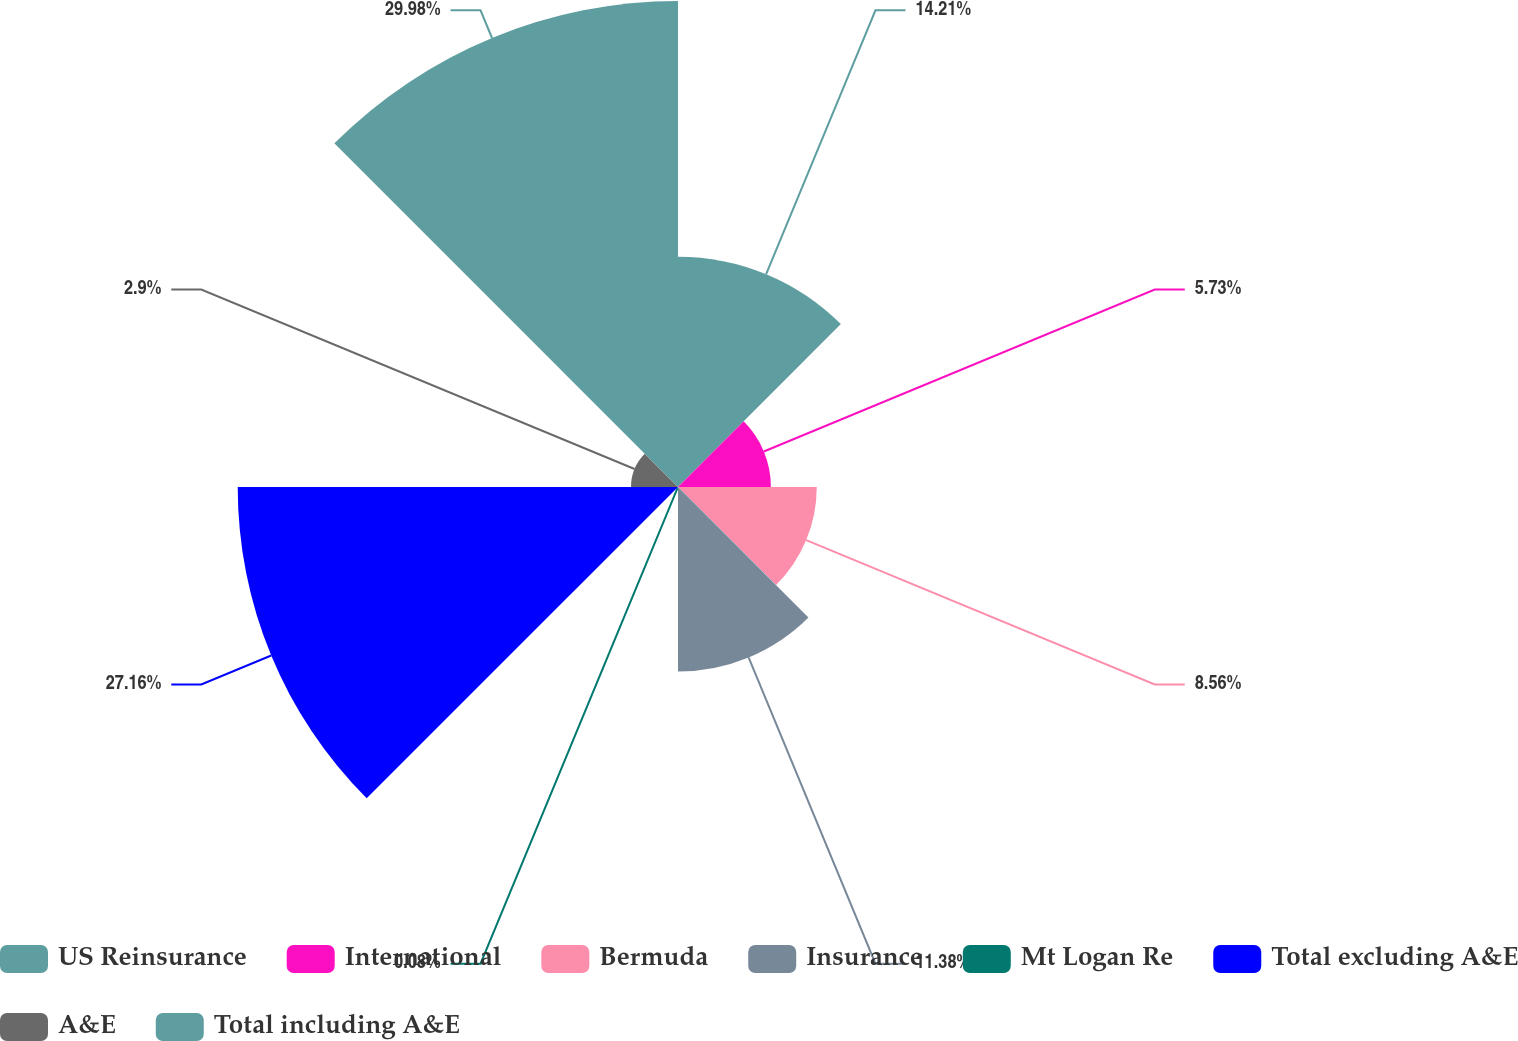Convert chart to OTSL. <chart><loc_0><loc_0><loc_500><loc_500><pie_chart><fcel>US Reinsurance<fcel>International<fcel>Bermuda<fcel>Insurance<fcel>Mt Logan Re<fcel>Total excluding A&E<fcel>A&E<fcel>Total including A&E<nl><fcel>14.21%<fcel>5.73%<fcel>8.56%<fcel>11.38%<fcel>0.08%<fcel>27.16%<fcel>2.9%<fcel>29.98%<nl></chart> 